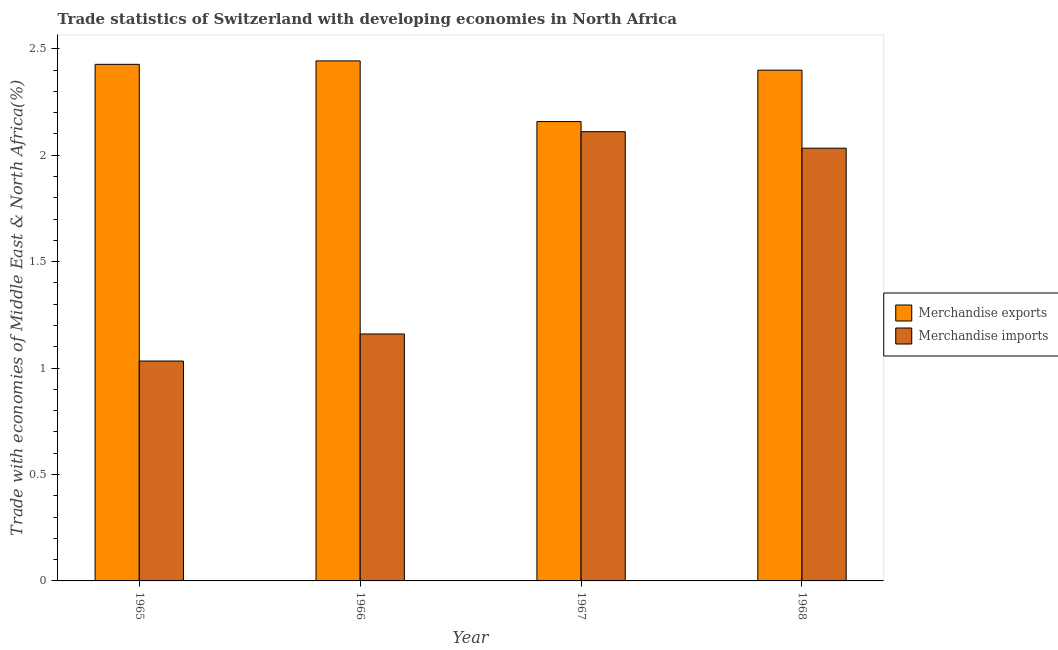How many groups of bars are there?
Provide a short and direct response. 4. Are the number of bars per tick equal to the number of legend labels?
Offer a terse response. Yes. How many bars are there on the 1st tick from the left?
Give a very brief answer. 2. What is the label of the 4th group of bars from the left?
Your answer should be very brief. 1968. In how many cases, is the number of bars for a given year not equal to the number of legend labels?
Your answer should be compact. 0. What is the merchandise exports in 1966?
Provide a short and direct response. 2.44. Across all years, what is the maximum merchandise imports?
Offer a terse response. 2.11. Across all years, what is the minimum merchandise exports?
Provide a succinct answer. 2.16. In which year was the merchandise imports maximum?
Keep it short and to the point. 1967. In which year was the merchandise exports minimum?
Give a very brief answer. 1967. What is the total merchandise imports in the graph?
Keep it short and to the point. 6.34. What is the difference between the merchandise exports in 1966 and that in 1967?
Keep it short and to the point. 0.29. What is the difference between the merchandise exports in 1965 and the merchandise imports in 1966?
Your answer should be very brief. -0.02. What is the average merchandise exports per year?
Offer a very short reply. 2.36. In the year 1967, what is the difference between the merchandise exports and merchandise imports?
Your answer should be very brief. 0. In how many years, is the merchandise exports greater than 0.1 %?
Offer a terse response. 4. What is the ratio of the merchandise imports in 1967 to that in 1968?
Offer a terse response. 1.04. Is the merchandise imports in 1966 less than that in 1968?
Provide a short and direct response. Yes. What is the difference between the highest and the second highest merchandise exports?
Your response must be concise. 0.02. What is the difference between the highest and the lowest merchandise exports?
Give a very brief answer. 0.29. What does the 1st bar from the right in 1968 represents?
Ensure brevity in your answer.  Merchandise imports. How many bars are there?
Offer a terse response. 8. Are all the bars in the graph horizontal?
Give a very brief answer. No. How many years are there in the graph?
Make the answer very short. 4. What is the difference between two consecutive major ticks on the Y-axis?
Provide a succinct answer. 0.5. Does the graph contain any zero values?
Your answer should be compact. No. Does the graph contain grids?
Your answer should be compact. No. Where does the legend appear in the graph?
Your answer should be compact. Center right. How are the legend labels stacked?
Provide a succinct answer. Vertical. What is the title of the graph?
Make the answer very short. Trade statistics of Switzerland with developing economies in North Africa. What is the label or title of the Y-axis?
Your response must be concise. Trade with economies of Middle East & North Africa(%). What is the Trade with economies of Middle East & North Africa(%) of Merchandise exports in 1965?
Offer a very short reply. 2.43. What is the Trade with economies of Middle East & North Africa(%) of Merchandise imports in 1965?
Provide a short and direct response. 1.03. What is the Trade with economies of Middle East & North Africa(%) in Merchandise exports in 1966?
Make the answer very short. 2.44. What is the Trade with economies of Middle East & North Africa(%) of Merchandise imports in 1966?
Give a very brief answer. 1.16. What is the Trade with economies of Middle East & North Africa(%) in Merchandise exports in 1967?
Keep it short and to the point. 2.16. What is the Trade with economies of Middle East & North Africa(%) in Merchandise imports in 1967?
Provide a succinct answer. 2.11. What is the Trade with economies of Middle East & North Africa(%) of Merchandise exports in 1968?
Give a very brief answer. 2.4. What is the Trade with economies of Middle East & North Africa(%) of Merchandise imports in 1968?
Your response must be concise. 2.03. Across all years, what is the maximum Trade with economies of Middle East & North Africa(%) of Merchandise exports?
Provide a short and direct response. 2.44. Across all years, what is the maximum Trade with economies of Middle East & North Africa(%) in Merchandise imports?
Your answer should be compact. 2.11. Across all years, what is the minimum Trade with economies of Middle East & North Africa(%) in Merchandise exports?
Your answer should be very brief. 2.16. Across all years, what is the minimum Trade with economies of Middle East & North Africa(%) of Merchandise imports?
Provide a succinct answer. 1.03. What is the total Trade with economies of Middle East & North Africa(%) of Merchandise exports in the graph?
Offer a very short reply. 9.43. What is the total Trade with economies of Middle East & North Africa(%) of Merchandise imports in the graph?
Make the answer very short. 6.34. What is the difference between the Trade with economies of Middle East & North Africa(%) in Merchandise exports in 1965 and that in 1966?
Make the answer very short. -0.02. What is the difference between the Trade with economies of Middle East & North Africa(%) of Merchandise imports in 1965 and that in 1966?
Make the answer very short. -0.13. What is the difference between the Trade with economies of Middle East & North Africa(%) of Merchandise exports in 1965 and that in 1967?
Give a very brief answer. 0.27. What is the difference between the Trade with economies of Middle East & North Africa(%) of Merchandise imports in 1965 and that in 1967?
Offer a terse response. -1.08. What is the difference between the Trade with economies of Middle East & North Africa(%) in Merchandise exports in 1965 and that in 1968?
Provide a short and direct response. 0.03. What is the difference between the Trade with economies of Middle East & North Africa(%) in Merchandise imports in 1965 and that in 1968?
Keep it short and to the point. -1. What is the difference between the Trade with economies of Middle East & North Africa(%) in Merchandise exports in 1966 and that in 1967?
Offer a terse response. 0.29. What is the difference between the Trade with economies of Middle East & North Africa(%) of Merchandise imports in 1966 and that in 1967?
Give a very brief answer. -0.95. What is the difference between the Trade with economies of Middle East & North Africa(%) of Merchandise exports in 1966 and that in 1968?
Offer a very short reply. 0.04. What is the difference between the Trade with economies of Middle East & North Africa(%) in Merchandise imports in 1966 and that in 1968?
Your response must be concise. -0.87. What is the difference between the Trade with economies of Middle East & North Africa(%) in Merchandise exports in 1967 and that in 1968?
Offer a very short reply. -0.24. What is the difference between the Trade with economies of Middle East & North Africa(%) in Merchandise imports in 1967 and that in 1968?
Provide a short and direct response. 0.08. What is the difference between the Trade with economies of Middle East & North Africa(%) in Merchandise exports in 1965 and the Trade with economies of Middle East & North Africa(%) in Merchandise imports in 1966?
Ensure brevity in your answer.  1.27. What is the difference between the Trade with economies of Middle East & North Africa(%) of Merchandise exports in 1965 and the Trade with economies of Middle East & North Africa(%) of Merchandise imports in 1967?
Make the answer very short. 0.32. What is the difference between the Trade with economies of Middle East & North Africa(%) of Merchandise exports in 1965 and the Trade with economies of Middle East & North Africa(%) of Merchandise imports in 1968?
Make the answer very short. 0.39. What is the difference between the Trade with economies of Middle East & North Africa(%) in Merchandise exports in 1966 and the Trade with economies of Middle East & North Africa(%) in Merchandise imports in 1967?
Your response must be concise. 0.33. What is the difference between the Trade with economies of Middle East & North Africa(%) in Merchandise exports in 1966 and the Trade with economies of Middle East & North Africa(%) in Merchandise imports in 1968?
Offer a very short reply. 0.41. What is the difference between the Trade with economies of Middle East & North Africa(%) of Merchandise exports in 1967 and the Trade with economies of Middle East & North Africa(%) of Merchandise imports in 1968?
Ensure brevity in your answer.  0.13. What is the average Trade with economies of Middle East & North Africa(%) in Merchandise exports per year?
Provide a short and direct response. 2.36. What is the average Trade with economies of Middle East & North Africa(%) of Merchandise imports per year?
Make the answer very short. 1.58. In the year 1965, what is the difference between the Trade with economies of Middle East & North Africa(%) in Merchandise exports and Trade with economies of Middle East & North Africa(%) in Merchandise imports?
Offer a very short reply. 1.39. In the year 1966, what is the difference between the Trade with economies of Middle East & North Africa(%) of Merchandise exports and Trade with economies of Middle East & North Africa(%) of Merchandise imports?
Offer a very short reply. 1.28. In the year 1967, what is the difference between the Trade with economies of Middle East & North Africa(%) of Merchandise exports and Trade with economies of Middle East & North Africa(%) of Merchandise imports?
Give a very brief answer. 0.05. In the year 1968, what is the difference between the Trade with economies of Middle East & North Africa(%) in Merchandise exports and Trade with economies of Middle East & North Africa(%) in Merchandise imports?
Offer a very short reply. 0.37. What is the ratio of the Trade with economies of Middle East & North Africa(%) in Merchandise exports in 1965 to that in 1966?
Keep it short and to the point. 0.99. What is the ratio of the Trade with economies of Middle East & North Africa(%) in Merchandise imports in 1965 to that in 1966?
Provide a short and direct response. 0.89. What is the ratio of the Trade with economies of Middle East & North Africa(%) of Merchandise exports in 1965 to that in 1967?
Provide a short and direct response. 1.12. What is the ratio of the Trade with economies of Middle East & North Africa(%) of Merchandise imports in 1965 to that in 1967?
Offer a terse response. 0.49. What is the ratio of the Trade with economies of Middle East & North Africa(%) of Merchandise exports in 1965 to that in 1968?
Make the answer very short. 1.01. What is the ratio of the Trade with economies of Middle East & North Africa(%) in Merchandise imports in 1965 to that in 1968?
Ensure brevity in your answer.  0.51. What is the ratio of the Trade with economies of Middle East & North Africa(%) in Merchandise exports in 1966 to that in 1967?
Provide a short and direct response. 1.13. What is the ratio of the Trade with economies of Middle East & North Africa(%) in Merchandise imports in 1966 to that in 1967?
Your answer should be compact. 0.55. What is the ratio of the Trade with economies of Middle East & North Africa(%) in Merchandise exports in 1966 to that in 1968?
Keep it short and to the point. 1.02. What is the ratio of the Trade with economies of Middle East & North Africa(%) in Merchandise imports in 1966 to that in 1968?
Your answer should be very brief. 0.57. What is the ratio of the Trade with economies of Middle East & North Africa(%) in Merchandise exports in 1967 to that in 1968?
Offer a terse response. 0.9. What is the ratio of the Trade with economies of Middle East & North Africa(%) in Merchandise imports in 1967 to that in 1968?
Provide a short and direct response. 1.04. What is the difference between the highest and the second highest Trade with economies of Middle East & North Africa(%) of Merchandise exports?
Provide a short and direct response. 0.02. What is the difference between the highest and the second highest Trade with economies of Middle East & North Africa(%) in Merchandise imports?
Make the answer very short. 0.08. What is the difference between the highest and the lowest Trade with economies of Middle East & North Africa(%) in Merchandise exports?
Give a very brief answer. 0.29. What is the difference between the highest and the lowest Trade with economies of Middle East & North Africa(%) in Merchandise imports?
Provide a succinct answer. 1.08. 